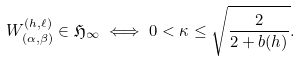Convert formula to latex. <formula><loc_0><loc_0><loc_500><loc_500>W _ { ( \alpha , \beta ) } ^ { ( h , \ell ) } \in \mathfrak { H } _ { \infty } \iff 0 < \kappa \leq \sqrt { \frac { 2 } { 2 + b ( h ) } } .</formula> 